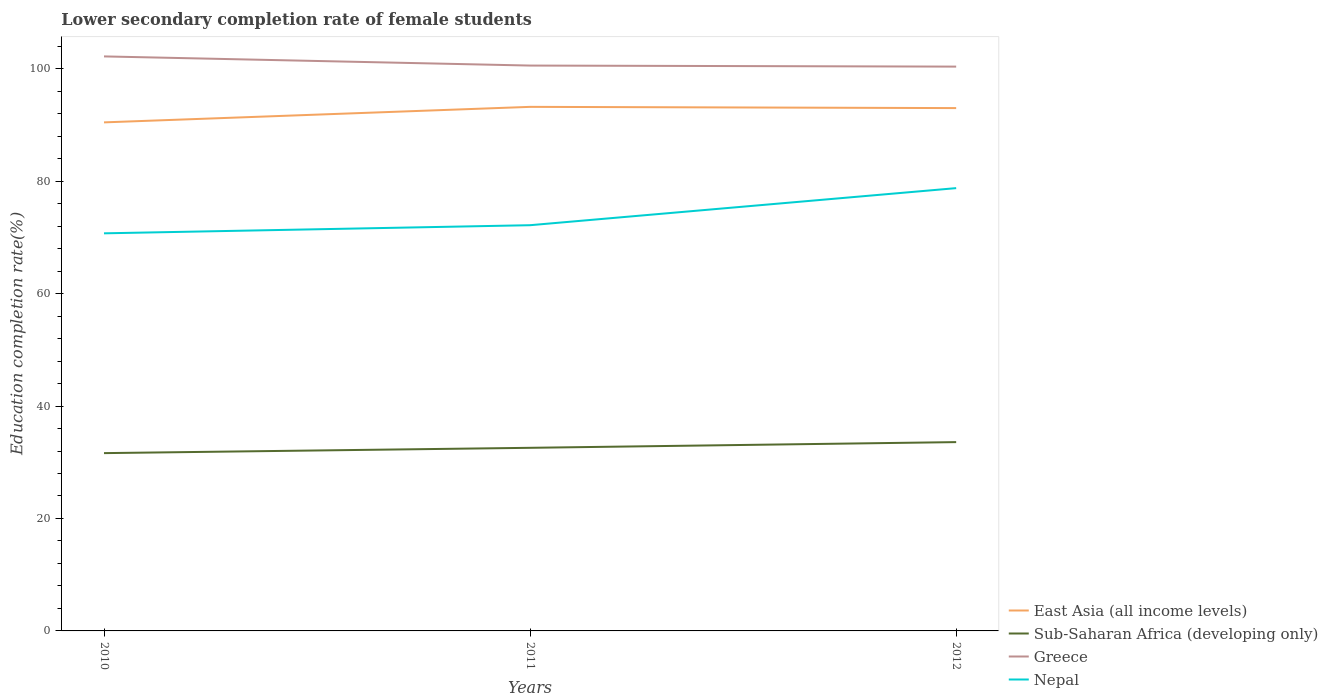How many different coloured lines are there?
Your answer should be compact. 4. Does the line corresponding to Nepal intersect with the line corresponding to Greece?
Make the answer very short. No. Is the number of lines equal to the number of legend labels?
Your response must be concise. Yes. Across all years, what is the maximum lower secondary completion rate of female students in Nepal?
Your answer should be very brief. 70.72. What is the total lower secondary completion rate of female students in East Asia (all income levels) in the graph?
Offer a terse response. -2.76. What is the difference between the highest and the second highest lower secondary completion rate of female students in Sub-Saharan Africa (developing only)?
Ensure brevity in your answer.  1.96. Is the lower secondary completion rate of female students in Sub-Saharan Africa (developing only) strictly greater than the lower secondary completion rate of female students in Nepal over the years?
Offer a terse response. Yes. How many years are there in the graph?
Offer a very short reply. 3. Are the values on the major ticks of Y-axis written in scientific E-notation?
Provide a short and direct response. No. Does the graph contain any zero values?
Keep it short and to the point. No. Where does the legend appear in the graph?
Provide a short and direct response. Bottom right. How are the legend labels stacked?
Provide a short and direct response. Vertical. What is the title of the graph?
Ensure brevity in your answer.  Lower secondary completion rate of female students. What is the label or title of the Y-axis?
Provide a succinct answer. Education completion rate(%). What is the Education completion rate(%) of East Asia (all income levels) in 2010?
Your answer should be very brief. 90.46. What is the Education completion rate(%) of Sub-Saharan Africa (developing only) in 2010?
Ensure brevity in your answer.  31.63. What is the Education completion rate(%) in Greece in 2010?
Offer a very short reply. 102.19. What is the Education completion rate(%) of Nepal in 2010?
Ensure brevity in your answer.  70.72. What is the Education completion rate(%) in East Asia (all income levels) in 2011?
Give a very brief answer. 93.22. What is the Education completion rate(%) of Sub-Saharan Africa (developing only) in 2011?
Offer a very short reply. 32.57. What is the Education completion rate(%) of Greece in 2011?
Offer a terse response. 100.56. What is the Education completion rate(%) in Nepal in 2011?
Make the answer very short. 72.17. What is the Education completion rate(%) in East Asia (all income levels) in 2012?
Your response must be concise. 93. What is the Education completion rate(%) of Sub-Saharan Africa (developing only) in 2012?
Offer a terse response. 33.58. What is the Education completion rate(%) in Greece in 2012?
Provide a succinct answer. 100.38. What is the Education completion rate(%) of Nepal in 2012?
Offer a very short reply. 78.76. Across all years, what is the maximum Education completion rate(%) in East Asia (all income levels)?
Keep it short and to the point. 93.22. Across all years, what is the maximum Education completion rate(%) of Sub-Saharan Africa (developing only)?
Your answer should be very brief. 33.58. Across all years, what is the maximum Education completion rate(%) of Greece?
Make the answer very short. 102.19. Across all years, what is the maximum Education completion rate(%) of Nepal?
Make the answer very short. 78.76. Across all years, what is the minimum Education completion rate(%) of East Asia (all income levels)?
Give a very brief answer. 90.46. Across all years, what is the minimum Education completion rate(%) of Sub-Saharan Africa (developing only)?
Provide a succinct answer. 31.63. Across all years, what is the minimum Education completion rate(%) in Greece?
Provide a succinct answer. 100.38. Across all years, what is the minimum Education completion rate(%) in Nepal?
Offer a very short reply. 70.72. What is the total Education completion rate(%) in East Asia (all income levels) in the graph?
Your answer should be very brief. 276.68. What is the total Education completion rate(%) of Sub-Saharan Africa (developing only) in the graph?
Provide a succinct answer. 97.78. What is the total Education completion rate(%) of Greece in the graph?
Offer a terse response. 303.14. What is the total Education completion rate(%) of Nepal in the graph?
Keep it short and to the point. 221.65. What is the difference between the Education completion rate(%) in East Asia (all income levels) in 2010 and that in 2011?
Give a very brief answer. -2.76. What is the difference between the Education completion rate(%) of Sub-Saharan Africa (developing only) in 2010 and that in 2011?
Ensure brevity in your answer.  -0.94. What is the difference between the Education completion rate(%) in Greece in 2010 and that in 2011?
Your answer should be compact. 1.63. What is the difference between the Education completion rate(%) of Nepal in 2010 and that in 2011?
Provide a succinct answer. -1.44. What is the difference between the Education completion rate(%) in East Asia (all income levels) in 2010 and that in 2012?
Your answer should be compact. -2.54. What is the difference between the Education completion rate(%) in Sub-Saharan Africa (developing only) in 2010 and that in 2012?
Offer a very short reply. -1.96. What is the difference between the Education completion rate(%) of Greece in 2010 and that in 2012?
Ensure brevity in your answer.  1.81. What is the difference between the Education completion rate(%) in Nepal in 2010 and that in 2012?
Offer a very short reply. -8.04. What is the difference between the Education completion rate(%) of East Asia (all income levels) in 2011 and that in 2012?
Provide a short and direct response. 0.22. What is the difference between the Education completion rate(%) of Sub-Saharan Africa (developing only) in 2011 and that in 2012?
Provide a short and direct response. -1.01. What is the difference between the Education completion rate(%) in Greece in 2011 and that in 2012?
Offer a very short reply. 0.19. What is the difference between the Education completion rate(%) in Nepal in 2011 and that in 2012?
Make the answer very short. -6.6. What is the difference between the Education completion rate(%) in East Asia (all income levels) in 2010 and the Education completion rate(%) in Sub-Saharan Africa (developing only) in 2011?
Your answer should be compact. 57.89. What is the difference between the Education completion rate(%) of East Asia (all income levels) in 2010 and the Education completion rate(%) of Greece in 2011?
Keep it short and to the point. -10.11. What is the difference between the Education completion rate(%) of East Asia (all income levels) in 2010 and the Education completion rate(%) of Nepal in 2011?
Provide a short and direct response. 18.29. What is the difference between the Education completion rate(%) in Sub-Saharan Africa (developing only) in 2010 and the Education completion rate(%) in Greece in 2011?
Offer a very short reply. -68.94. What is the difference between the Education completion rate(%) of Sub-Saharan Africa (developing only) in 2010 and the Education completion rate(%) of Nepal in 2011?
Make the answer very short. -40.54. What is the difference between the Education completion rate(%) in Greece in 2010 and the Education completion rate(%) in Nepal in 2011?
Offer a terse response. 30.02. What is the difference between the Education completion rate(%) of East Asia (all income levels) in 2010 and the Education completion rate(%) of Sub-Saharan Africa (developing only) in 2012?
Provide a short and direct response. 56.88. What is the difference between the Education completion rate(%) of East Asia (all income levels) in 2010 and the Education completion rate(%) of Greece in 2012?
Keep it short and to the point. -9.92. What is the difference between the Education completion rate(%) in East Asia (all income levels) in 2010 and the Education completion rate(%) in Nepal in 2012?
Make the answer very short. 11.7. What is the difference between the Education completion rate(%) in Sub-Saharan Africa (developing only) in 2010 and the Education completion rate(%) in Greece in 2012?
Ensure brevity in your answer.  -68.75. What is the difference between the Education completion rate(%) in Sub-Saharan Africa (developing only) in 2010 and the Education completion rate(%) in Nepal in 2012?
Provide a short and direct response. -47.14. What is the difference between the Education completion rate(%) in Greece in 2010 and the Education completion rate(%) in Nepal in 2012?
Your answer should be compact. 23.43. What is the difference between the Education completion rate(%) in East Asia (all income levels) in 2011 and the Education completion rate(%) in Sub-Saharan Africa (developing only) in 2012?
Make the answer very short. 59.63. What is the difference between the Education completion rate(%) of East Asia (all income levels) in 2011 and the Education completion rate(%) of Greece in 2012?
Provide a short and direct response. -7.16. What is the difference between the Education completion rate(%) of East Asia (all income levels) in 2011 and the Education completion rate(%) of Nepal in 2012?
Ensure brevity in your answer.  14.46. What is the difference between the Education completion rate(%) of Sub-Saharan Africa (developing only) in 2011 and the Education completion rate(%) of Greece in 2012?
Keep it short and to the point. -67.81. What is the difference between the Education completion rate(%) of Sub-Saharan Africa (developing only) in 2011 and the Education completion rate(%) of Nepal in 2012?
Make the answer very short. -46.19. What is the difference between the Education completion rate(%) in Greece in 2011 and the Education completion rate(%) in Nepal in 2012?
Your answer should be very brief. 21.8. What is the average Education completion rate(%) of East Asia (all income levels) per year?
Your response must be concise. 92.23. What is the average Education completion rate(%) of Sub-Saharan Africa (developing only) per year?
Provide a succinct answer. 32.59. What is the average Education completion rate(%) of Greece per year?
Offer a very short reply. 101.05. What is the average Education completion rate(%) of Nepal per year?
Your answer should be compact. 73.88. In the year 2010, what is the difference between the Education completion rate(%) of East Asia (all income levels) and Education completion rate(%) of Sub-Saharan Africa (developing only)?
Give a very brief answer. 58.83. In the year 2010, what is the difference between the Education completion rate(%) of East Asia (all income levels) and Education completion rate(%) of Greece?
Provide a succinct answer. -11.73. In the year 2010, what is the difference between the Education completion rate(%) in East Asia (all income levels) and Education completion rate(%) in Nepal?
Provide a short and direct response. 19.74. In the year 2010, what is the difference between the Education completion rate(%) in Sub-Saharan Africa (developing only) and Education completion rate(%) in Greece?
Provide a succinct answer. -70.57. In the year 2010, what is the difference between the Education completion rate(%) of Sub-Saharan Africa (developing only) and Education completion rate(%) of Nepal?
Give a very brief answer. -39.1. In the year 2010, what is the difference between the Education completion rate(%) of Greece and Education completion rate(%) of Nepal?
Ensure brevity in your answer.  31.47. In the year 2011, what is the difference between the Education completion rate(%) of East Asia (all income levels) and Education completion rate(%) of Sub-Saharan Africa (developing only)?
Offer a very short reply. 60.65. In the year 2011, what is the difference between the Education completion rate(%) in East Asia (all income levels) and Education completion rate(%) in Greece?
Offer a terse response. -7.35. In the year 2011, what is the difference between the Education completion rate(%) of East Asia (all income levels) and Education completion rate(%) of Nepal?
Give a very brief answer. 21.05. In the year 2011, what is the difference between the Education completion rate(%) of Sub-Saharan Africa (developing only) and Education completion rate(%) of Greece?
Your response must be concise. -67.99. In the year 2011, what is the difference between the Education completion rate(%) of Sub-Saharan Africa (developing only) and Education completion rate(%) of Nepal?
Offer a terse response. -39.6. In the year 2011, what is the difference between the Education completion rate(%) of Greece and Education completion rate(%) of Nepal?
Provide a succinct answer. 28.4. In the year 2012, what is the difference between the Education completion rate(%) in East Asia (all income levels) and Education completion rate(%) in Sub-Saharan Africa (developing only)?
Your answer should be very brief. 59.42. In the year 2012, what is the difference between the Education completion rate(%) in East Asia (all income levels) and Education completion rate(%) in Greece?
Provide a short and direct response. -7.38. In the year 2012, what is the difference between the Education completion rate(%) of East Asia (all income levels) and Education completion rate(%) of Nepal?
Give a very brief answer. 14.24. In the year 2012, what is the difference between the Education completion rate(%) of Sub-Saharan Africa (developing only) and Education completion rate(%) of Greece?
Your response must be concise. -66.79. In the year 2012, what is the difference between the Education completion rate(%) of Sub-Saharan Africa (developing only) and Education completion rate(%) of Nepal?
Your answer should be very brief. -45.18. In the year 2012, what is the difference between the Education completion rate(%) in Greece and Education completion rate(%) in Nepal?
Ensure brevity in your answer.  21.62. What is the ratio of the Education completion rate(%) of East Asia (all income levels) in 2010 to that in 2011?
Ensure brevity in your answer.  0.97. What is the ratio of the Education completion rate(%) of Greece in 2010 to that in 2011?
Ensure brevity in your answer.  1.02. What is the ratio of the Education completion rate(%) of Nepal in 2010 to that in 2011?
Your answer should be compact. 0.98. What is the ratio of the Education completion rate(%) of East Asia (all income levels) in 2010 to that in 2012?
Keep it short and to the point. 0.97. What is the ratio of the Education completion rate(%) in Sub-Saharan Africa (developing only) in 2010 to that in 2012?
Make the answer very short. 0.94. What is the ratio of the Education completion rate(%) in Greece in 2010 to that in 2012?
Keep it short and to the point. 1.02. What is the ratio of the Education completion rate(%) in Nepal in 2010 to that in 2012?
Your response must be concise. 0.9. What is the ratio of the Education completion rate(%) of Sub-Saharan Africa (developing only) in 2011 to that in 2012?
Make the answer very short. 0.97. What is the ratio of the Education completion rate(%) in Nepal in 2011 to that in 2012?
Provide a succinct answer. 0.92. What is the difference between the highest and the second highest Education completion rate(%) in East Asia (all income levels)?
Keep it short and to the point. 0.22. What is the difference between the highest and the second highest Education completion rate(%) of Sub-Saharan Africa (developing only)?
Offer a very short reply. 1.01. What is the difference between the highest and the second highest Education completion rate(%) of Greece?
Your response must be concise. 1.63. What is the difference between the highest and the second highest Education completion rate(%) of Nepal?
Provide a succinct answer. 6.6. What is the difference between the highest and the lowest Education completion rate(%) in East Asia (all income levels)?
Make the answer very short. 2.76. What is the difference between the highest and the lowest Education completion rate(%) in Sub-Saharan Africa (developing only)?
Make the answer very short. 1.96. What is the difference between the highest and the lowest Education completion rate(%) in Greece?
Keep it short and to the point. 1.81. What is the difference between the highest and the lowest Education completion rate(%) in Nepal?
Ensure brevity in your answer.  8.04. 